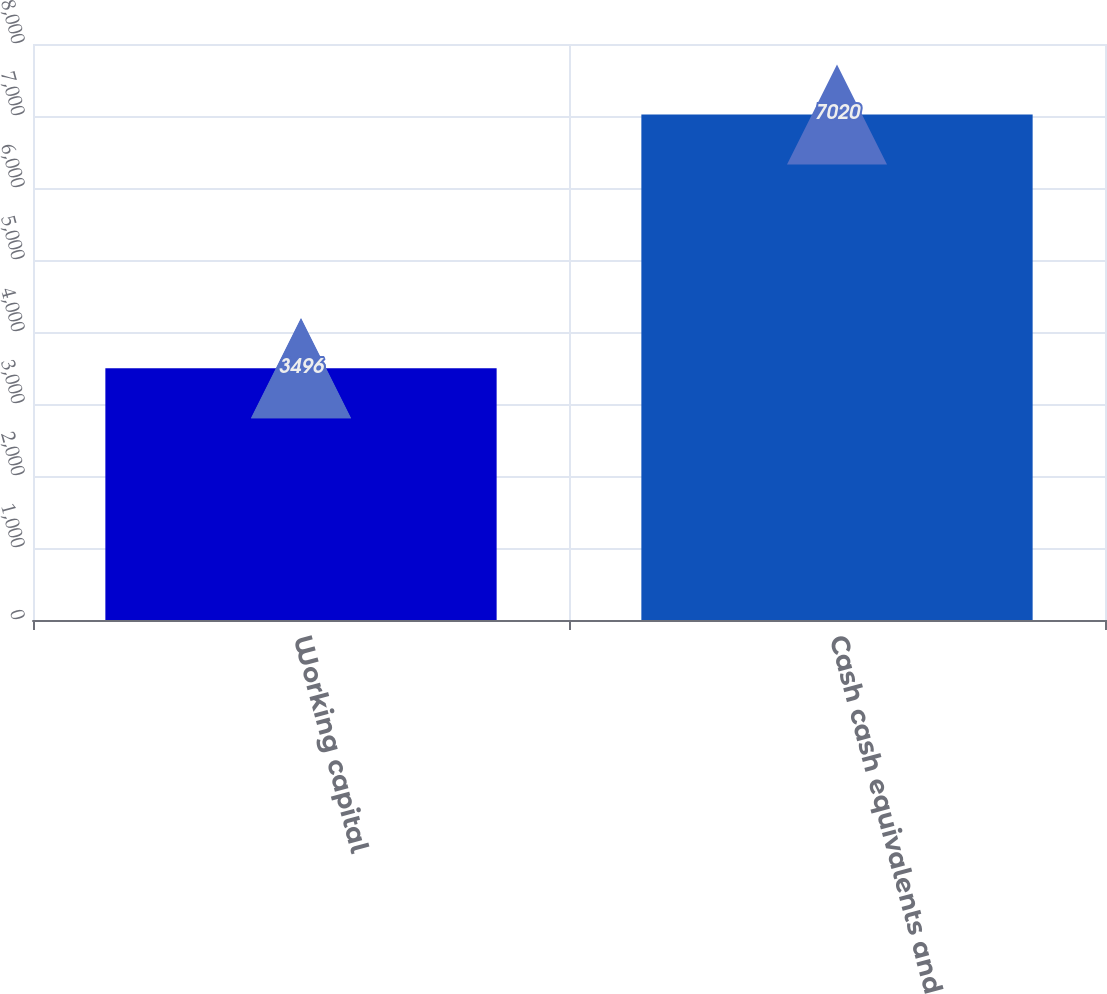Convert chart. <chart><loc_0><loc_0><loc_500><loc_500><bar_chart><fcel>Working capital<fcel>Cash cash equivalents and<nl><fcel>3496<fcel>7020<nl></chart> 